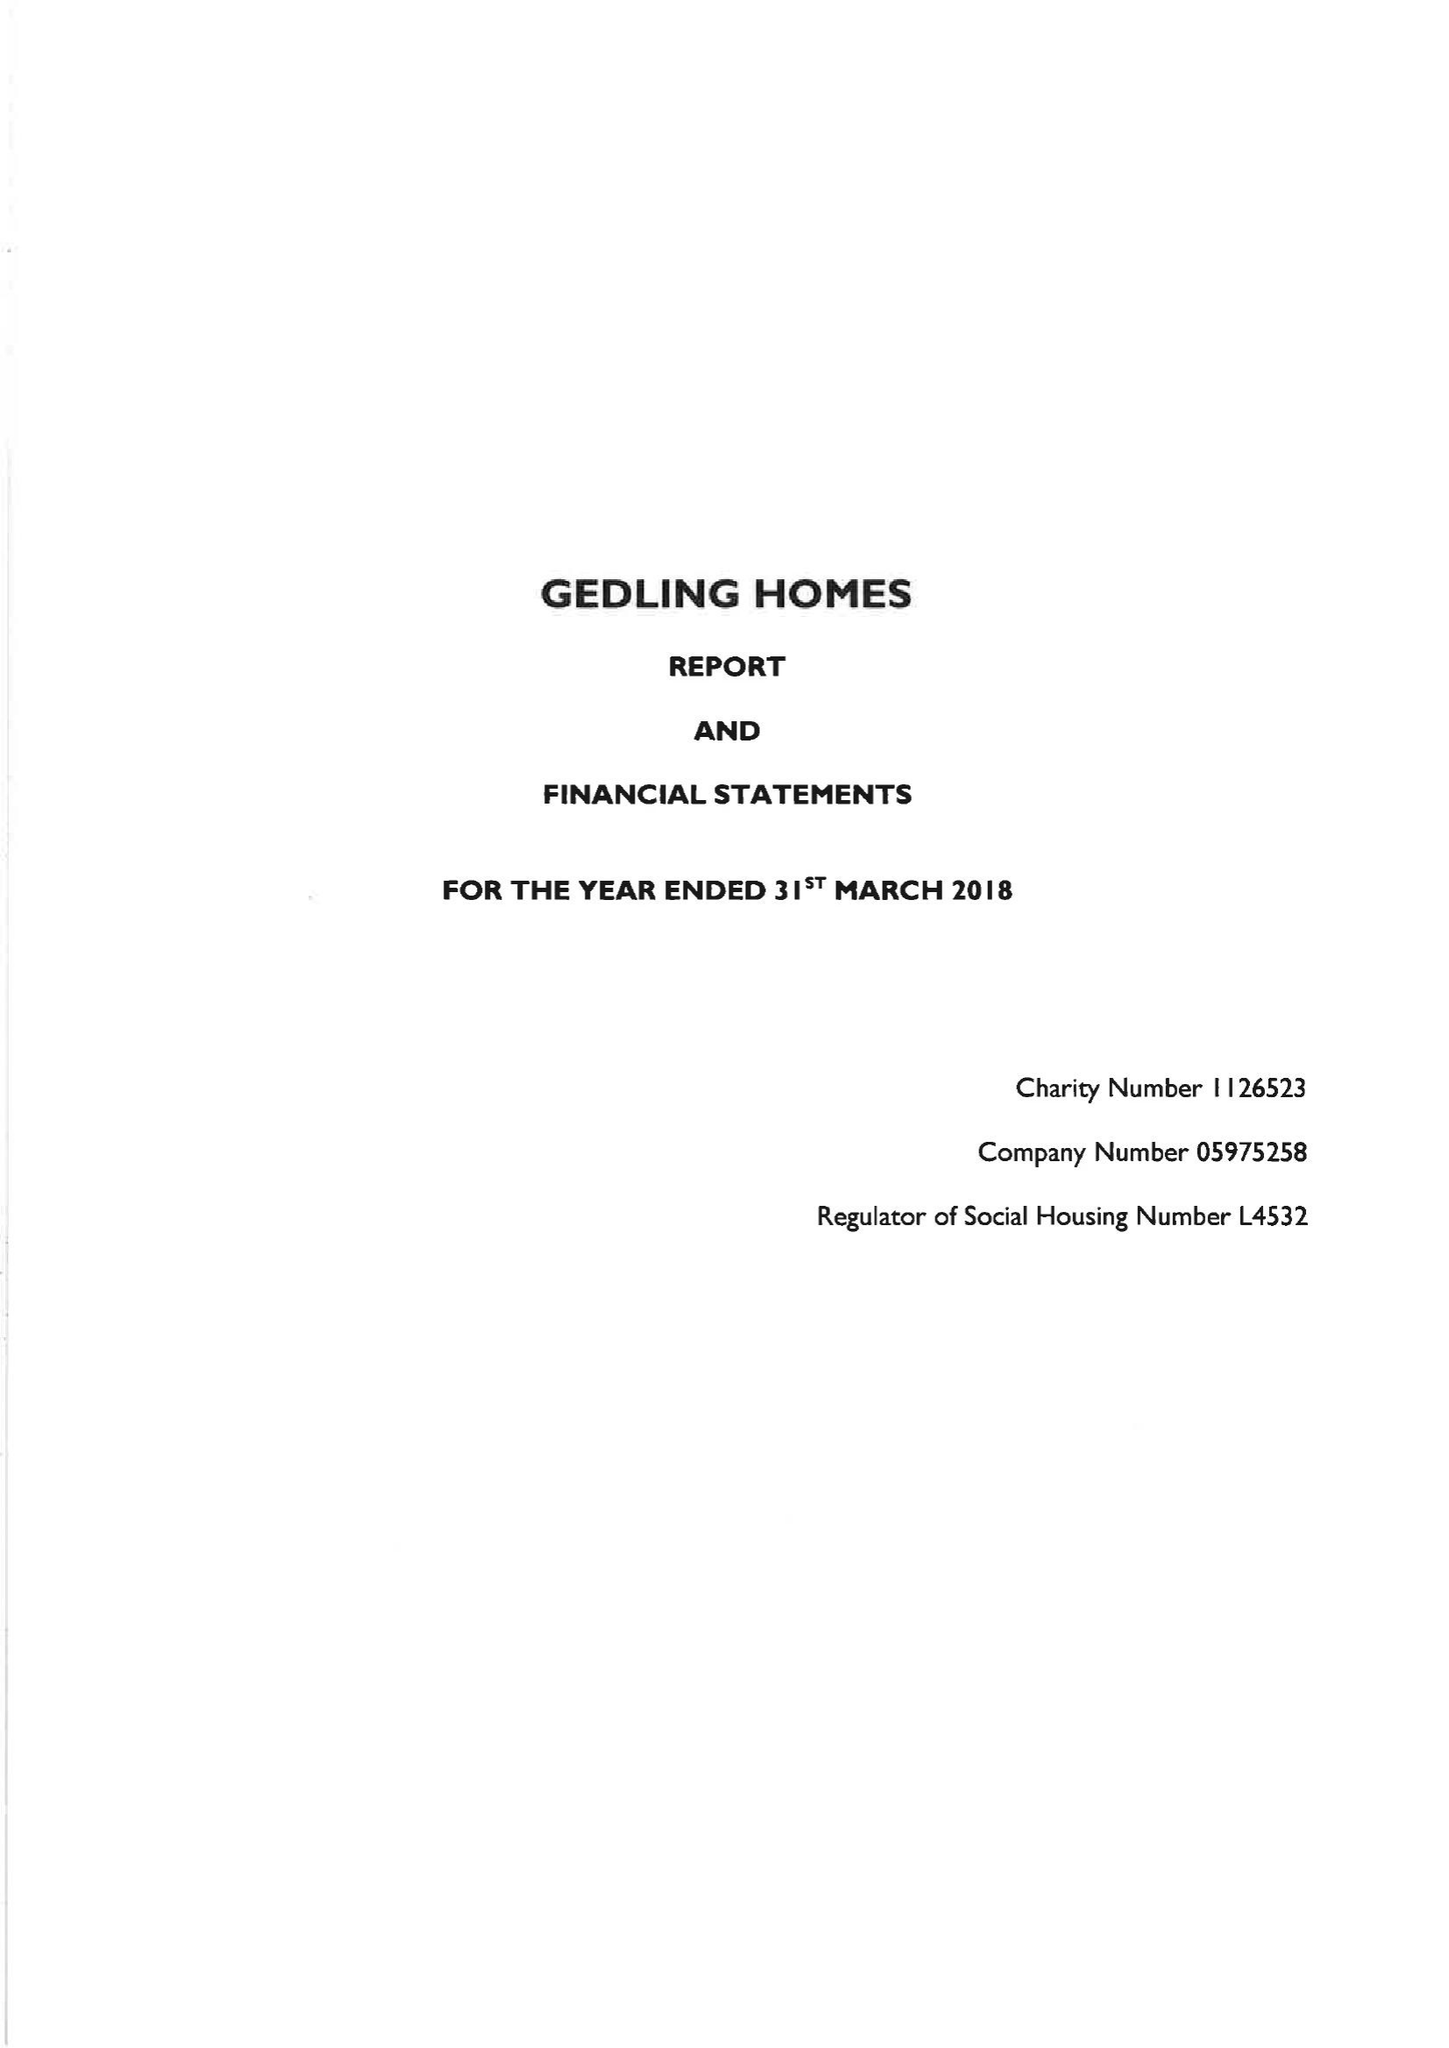What is the value for the address__postcode?
Answer the question using a single word or phrase. OL6 7AT 